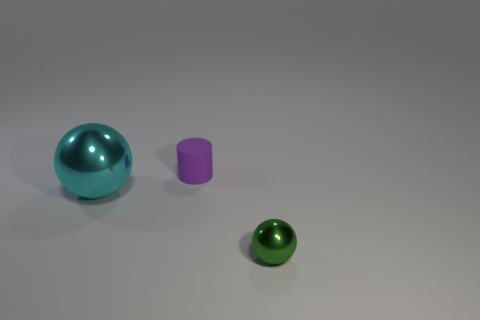Are there any other things that are the same shape as the purple matte object?
Offer a terse response. No. How many green balls are there?
Offer a very short reply. 1. How many brown cylinders are the same material as the large cyan sphere?
Provide a succinct answer. 0. How many objects are either metallic balls on the left side of the tiny matte cylinder or yellow metallic objects?
Keep it short and to the point. 1. Is the number of large metal balls behind the small green shiny thing less than the number of things right of the cyan shiny thing?
Your response must be concise. Yes. Are there any big cyan things in front of the tiny purple matte cylinder?
Your answer should be compact. Yes. How many things are either tiny objects in front of the small rubber cylinder or small things that are in front of the tiny purple cylinder?
Offer a very short reply. 1. How many tiny metallic spheres have the same color as the small metallic thing?
Ensure brevity in your answer.  0. There is a large shiny object that is the same shape as the small shiny object; what is its color?
Your answer should be compact. Cyan. What is the shape of the thing that is both behind the green object and in front of the tiny purple rubber thing?
Give a very brief answer. Sphere. 